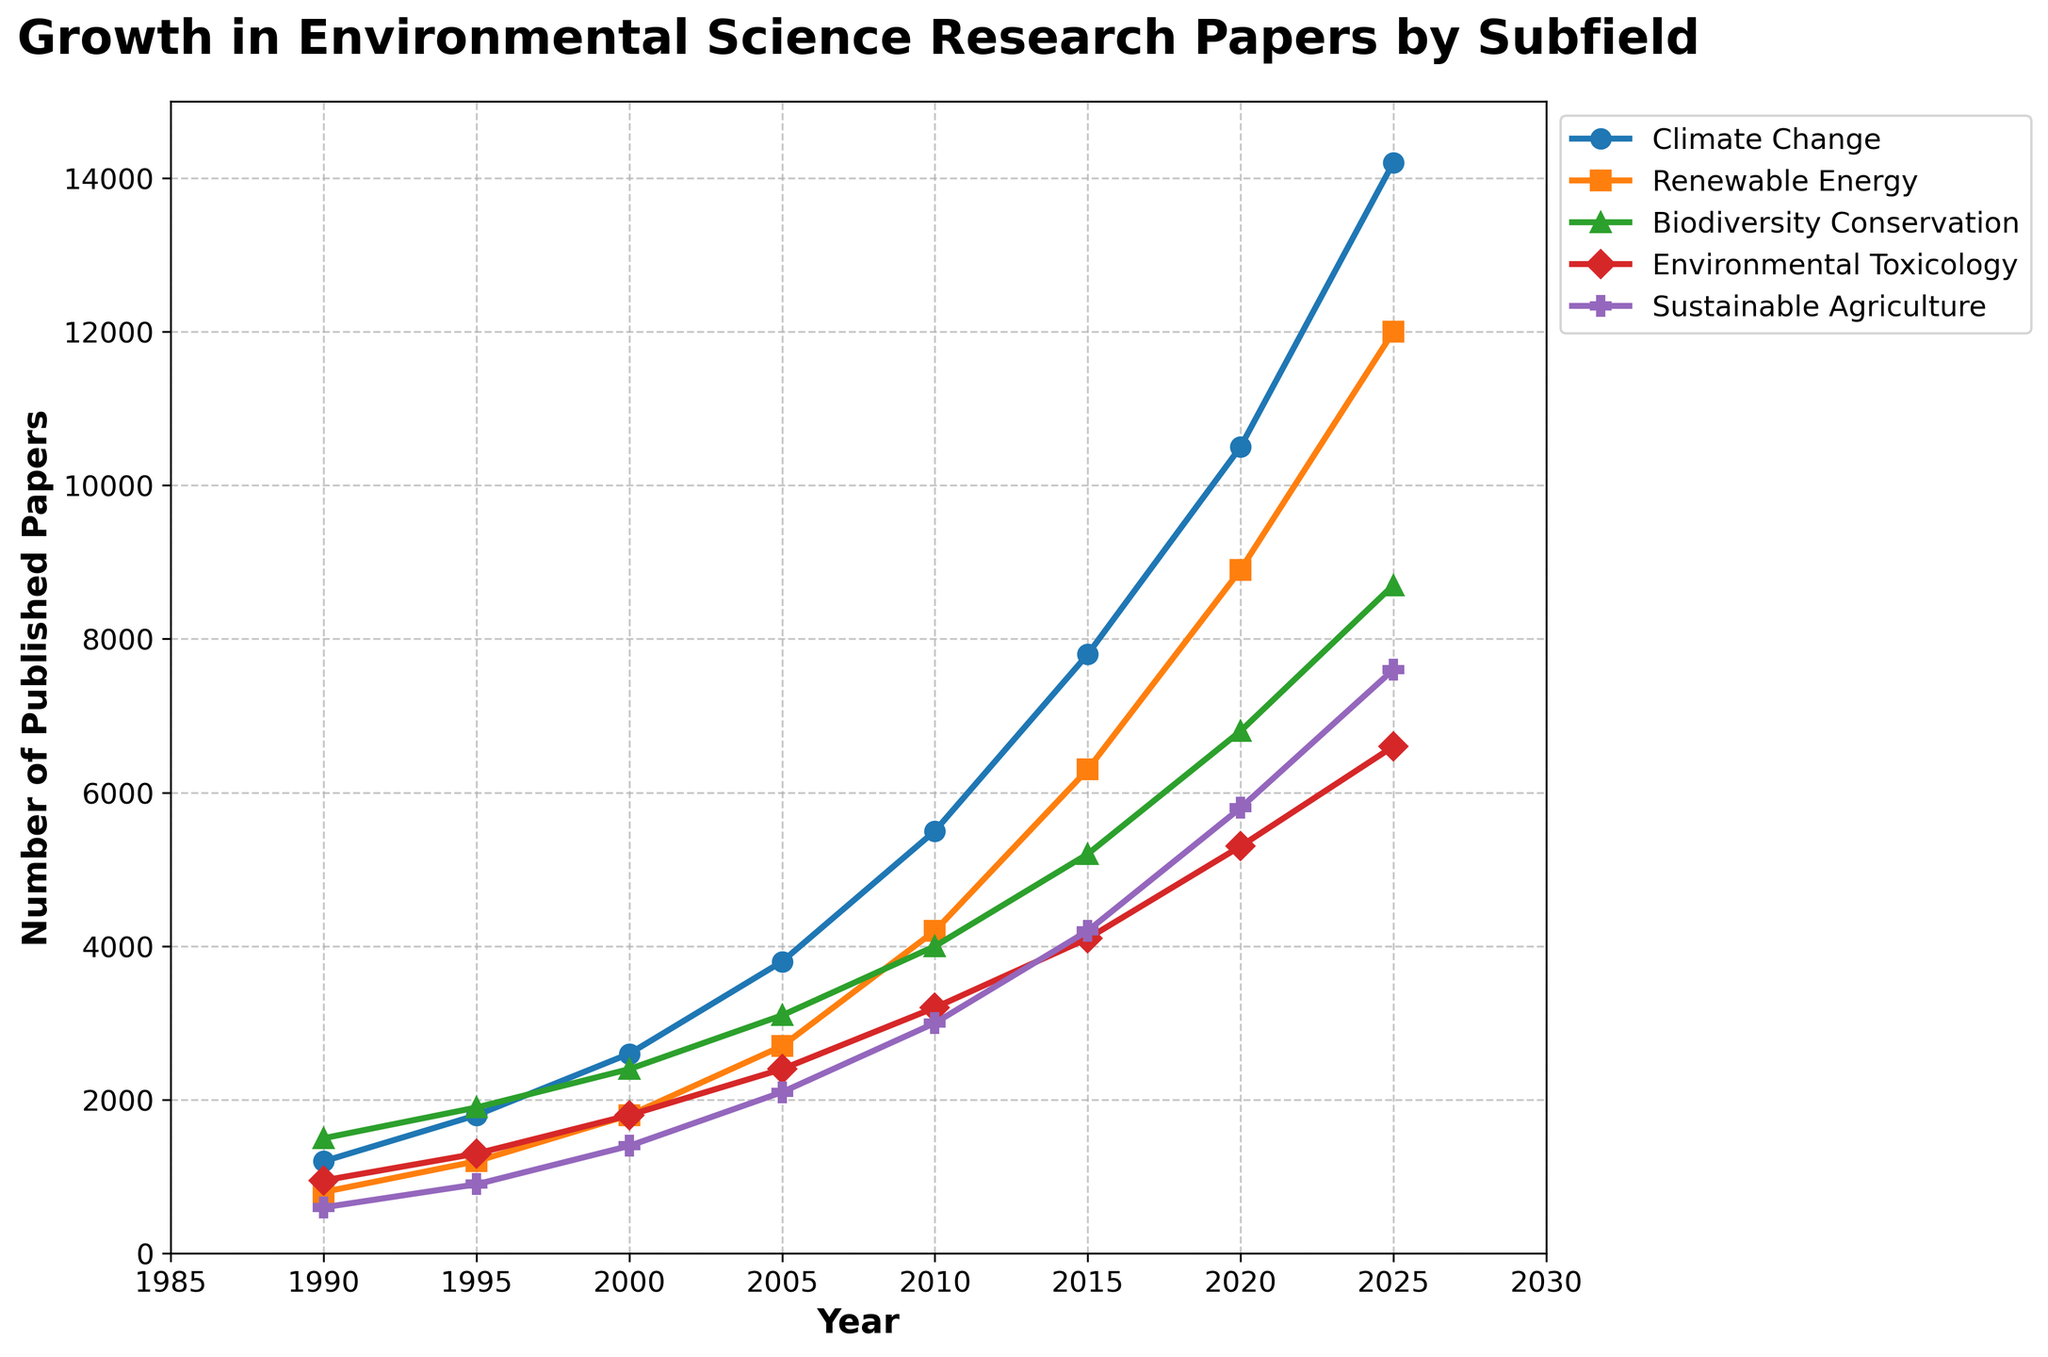When did the subfield of 'Climate Change' have the highest number of published papers? The visual representation shows that 'Climate Change' reached its peak number of publications in 2025, as depicted by the highest point on its plotted line.
Answer: 2025 Which subfield had more published papers in 2010: 'Renewable Energy' or 'Sustainable Agriculture'? By observing the chart, the line representing 'Renewable Energy' in 2010 is higher than the line representing 'Sustainable Agriculture'. Thus, 'Renewable Energy' had more published papers in that year.
Answer: Renewable Energy What is the total number of published papers across all subfields in 2000? Summing the values of all subfields for the year 2000: 2600 (Climate Change) + 1800 (Renewable Energy) + 2400 (Biodiversity Conservation) + 1800 (Environmental Toxicology) + 1400 (Sustainable Agriculture) equals 10000.
Answer: 10000 By how much did the number of published papers in 'Environmental Toxicology' increase from 1990 to 2020? Subtracting the number of published papers in 1990 from that in 2020 for 'Environmental Toxicology': 5300 (2020) - 950 (1990) equals 4350.
Answer: 4350 Which subfield experienced the steepest growth rate from 2010 to 2025? By visually assessing the slopes of the lines between 2010 and 2025, 'Climate Change' has the steepest incline compared to other subfields, indicating the highest growth rate.
Answer: Climate Change How does the number of published papers in 'Biodiversity Conservation' in 2005 compare to 'Sustainable Agriculture' in 2025? The figure indicates that 'Biodiversity Conservation' in 2005 had 3100 published papers, whereas 'Sustainable Agriculture' in 2025 had 7600 published papers. Comparing these values, 7600 is greater than 3100.
Answer: 7600 > 3100 What is the average number of published papers in 'Renewable Energy' over the entire period? Adding all the values for 'Renewable Energy' and dividing by the number of years: (800 + 1200 + 1800 + 2700 + 4200 + 6300 + 8900 + 12000)/8 = 48900/8 = 6112.5
Answer: 6112.5 Which subfields experienced a publication count of exactly 600 papers in 1990? According to the figure, 'Sustainable Agriculture' is the only subfield with a publication count of exactly 600 papers in 1990.
Answer: Sustainable Agriculture What is the difference in the number of published papers between 'Biodiversity Conservation' and 'Environmental Toxicology' in 2025? Subtracting the publication count of 'Environmental Toxicology' from 'Biodiversity Conservation' in 2025: 8700 (Biodiversity Conservation) - 6600 (Environmental Toxicology) equals 2100.
Answer: 2100 Which subfield appears in green and what is its publication trend from 1990 to 2025? Observing the colors used in the plot, the green line represents 'Biodiversity Conservation'. The trend shows a steady increase in the number of published papers from 1500 in 1990 to 8700 in 2025.
Answer: Biodiversity Conservation, increasing trend 